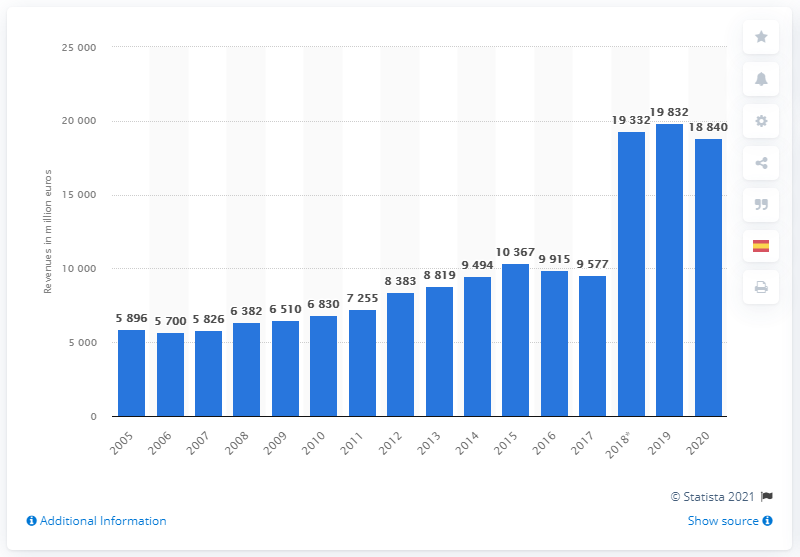List a handful of essential elements in this visual. Bayer CropScience generated approximately $58,960 in revenue in 2005. The revenue of Bayer CropScience in the year 2020 was 188,400. 